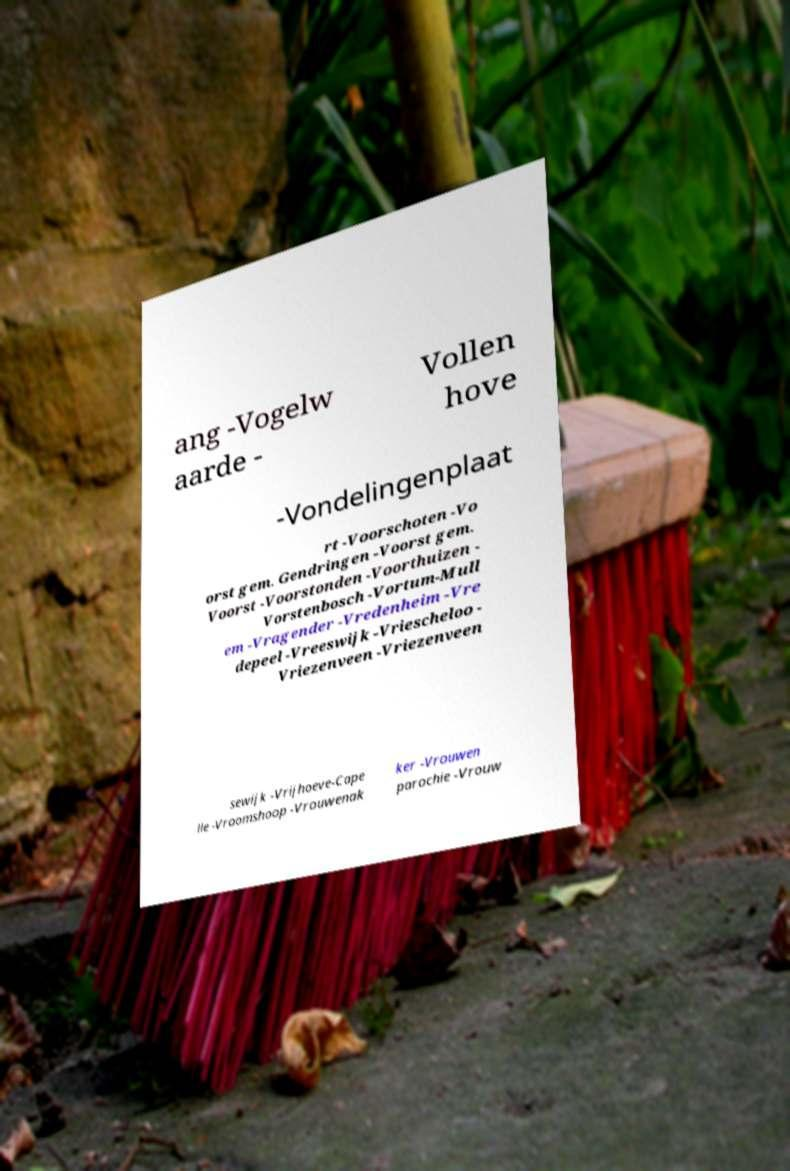Could you assist in decoding the text presented in this image and type it out clearly? ang -Vogelw aarde - Vollen hove -Vondelingenplaat rt -Voorschoten -Vo orst gem. Gendringen -Voorst gem. Voorst -Voorstonden -Voorthuizen - Vorstenbosch -Vortum-Mull em -Vragender -Vredenheim -Vre depeel -Vreeswijk -Vriescheloo - Vriezenveen -Vriezenveen sewijk -Vrijhoeve-Cape lle -Vroomshoop -Vrouwenak ker -Vrouwen parochie -Vrouw 